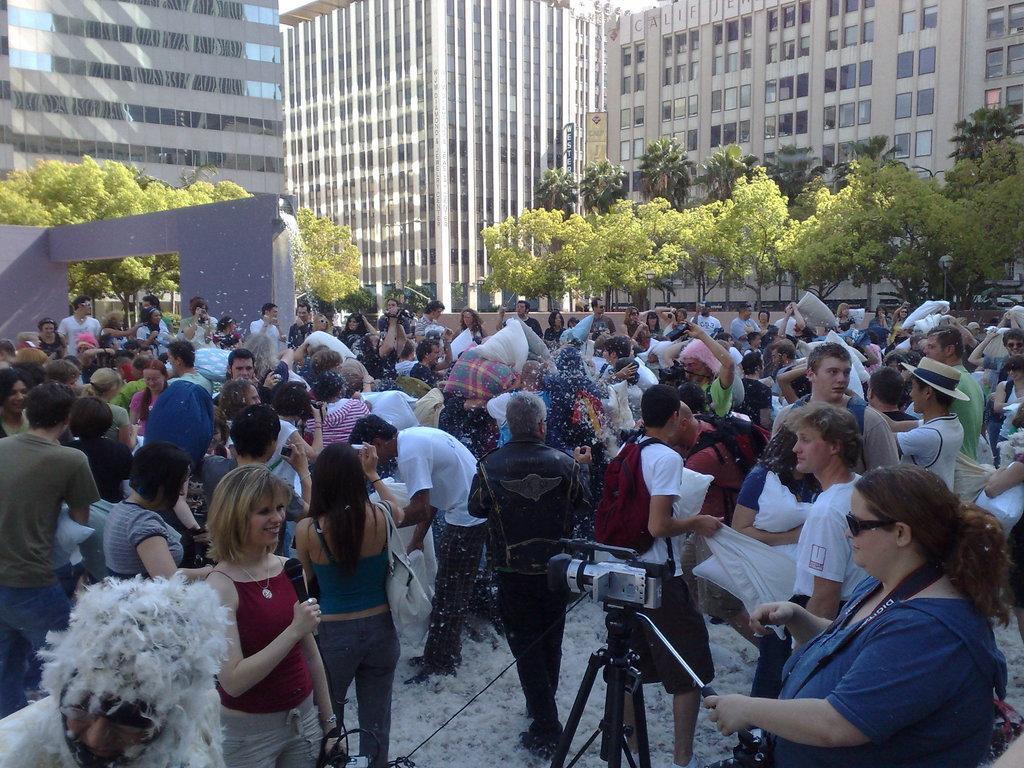In one or two sentences, can you explain what this image depicts? In this image we can see many persons on the ground, camera, trees, buildings and wall. 